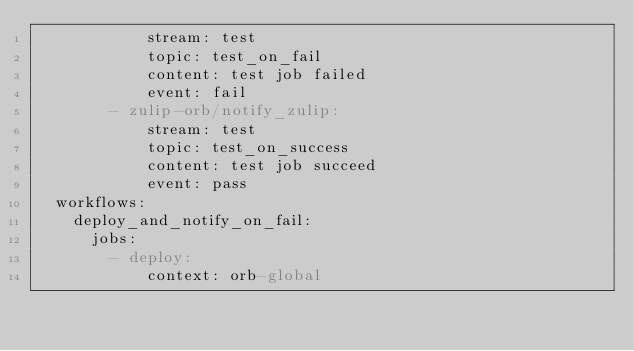<code> <loc_0><loc_0><loc_500><loc_500><_YAML_>            stream: test
            topic: test_on_fail
            content: test job failed
            event: fail
        - zulip-orb/notify_zulip:
            stream: test
            topic: test_on_success
            content: test job succeed
            event: pass
  workflows:
    deploy_and_notify_on_fail:
      jobs:
        - deploy:
            context: orb-global
</code> 